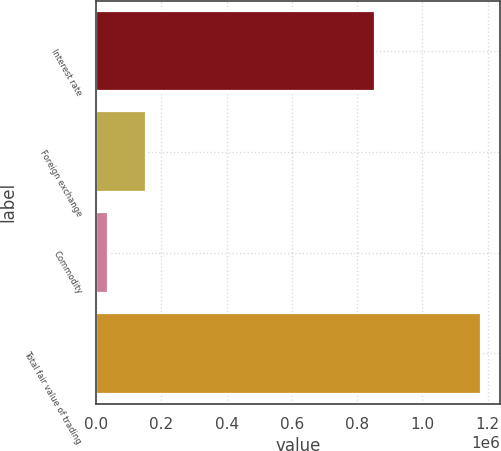Convert chart. <chart><loc_0><loc_0><loc_500><loc_500><bar_chart><fcel>Interest rate<fcel>Foreign exchange<fcel>Commodity<fcel>Total fair value of trading<nl><fcel>854679<fcel>153599<fcel>35738<fcel>1.18047e+06<nl></chart> 